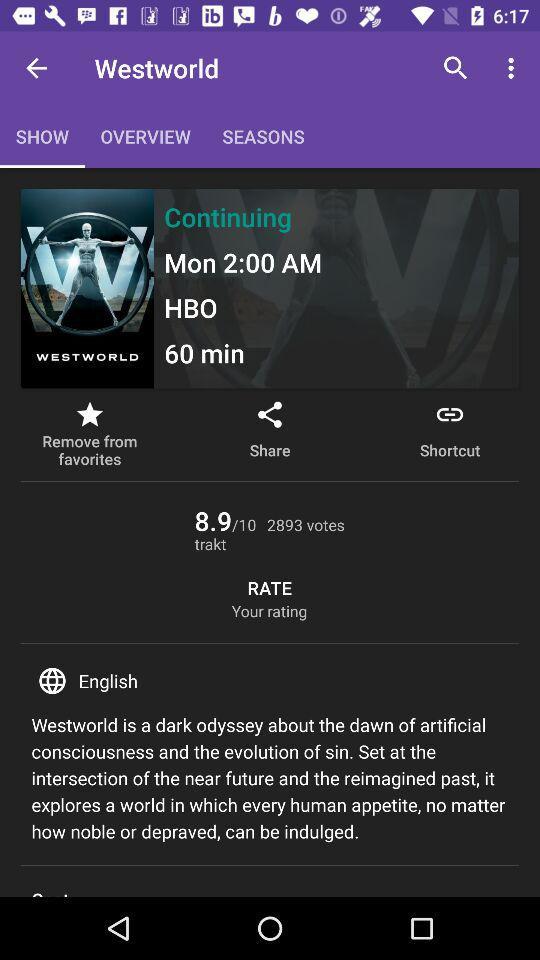Which channel will the show air on? The show will air on "HBO". 